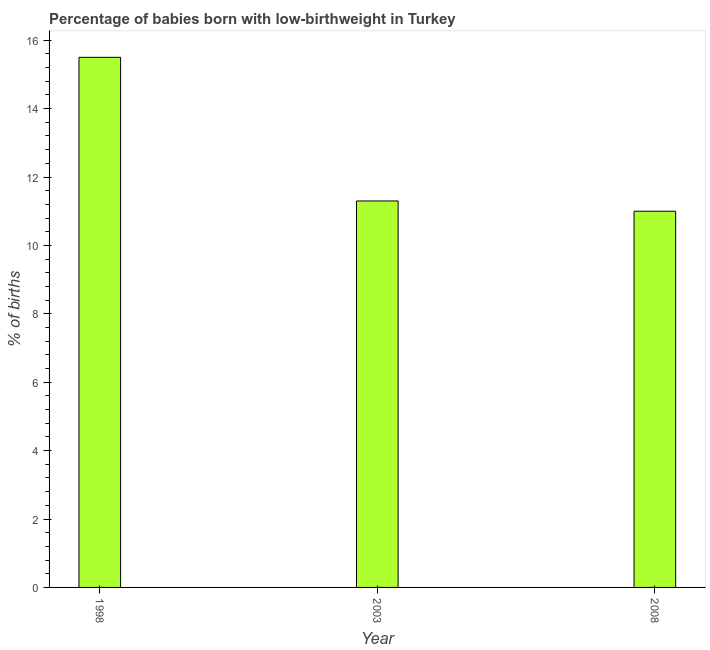Does the graph contain any zero values?
Your answer should be very brief. No. What is the title of the graph?
Make the answer very short. Percentage of babies born with low-birthweight in Turkey. What is the label or title of the Y-axis?
Your answer should be very brief. % of births. In which year was the percentage of babies who were born with low-birthweight minimum?
Ensure brevity in your answer.  2008. What is the sum of the percentage of babies who were born with low-birthweight?
Offer a very short reply. 37.8. What is the difference between the percentage of babies who were born with low-birthweight in 1998 and 2008?
Provide a succinct answer. 4.5. What is the average percentage of babies who were born with low-birthweight per year?
Keep it short and to the point. 12.6. What is the median percentage of babies who were born with low-birthweight?
Keep it short and to the point. 11.3. In how many years, is the percentage of babies who were born with low-birthweight greater than 6.4 %?
Ensure brevity in your answer.  3. Do a majority of the years between 1998 and 2003 (inclusive) have percentage of babies who were born with low-birthweight greater than 4 %?
Offer a very short reply. Yes. What is the ratio of the percentage of babies who were born with low-birthweight in 2003 to that in 2008?
Offer a terse response. 1.03. How many bars are there?
Provide a succinct answer. 3. Are all the bars in the graph horizontal?
Give a very brief answer. No. What is the difference between two consecutive major ticks on the Y-axis?
Your answer should be compact. 2. Are the values on the major ticks of Y-axis written in scientific E-notation?
Your answer should be very brief. No. What is the % of births of 1998?
Give a very brief answer. 15.5. What is the % of births in 2003?
Your answer should be compact. 11.3. What is the difference between the % of births in 1998 and 2003?
Your answer should be compact. 4.2. What is the difference between the % of births in 2003 and 2008?
Provide a succinct answer. 0.3. What is the ratio of the % of births in 1998 to that in 2003?
Your answer should be very brief. 1.37. What is the ratio of the % of births in 1998 to that in 2008?
Offer a terse response. 1.41. What is the ratio of the % of births in 2003 to that in 2008?
Your response must be concise. 1.03. 